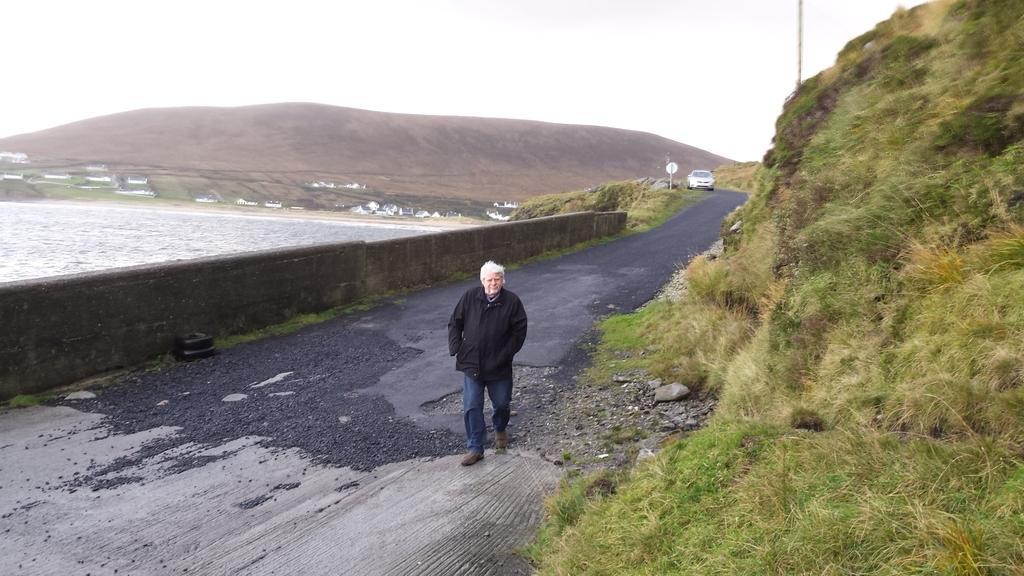In one or two sentences, can you explain what this image depicts? In this image there is a person walking on the road, behind the person there is a vehicle moving. On the right side of the image there is grass on the mountain. On the left side of the image there is a wall, behind the wall there is water. In the background there are like buildings, mountain, poles and the sky. 